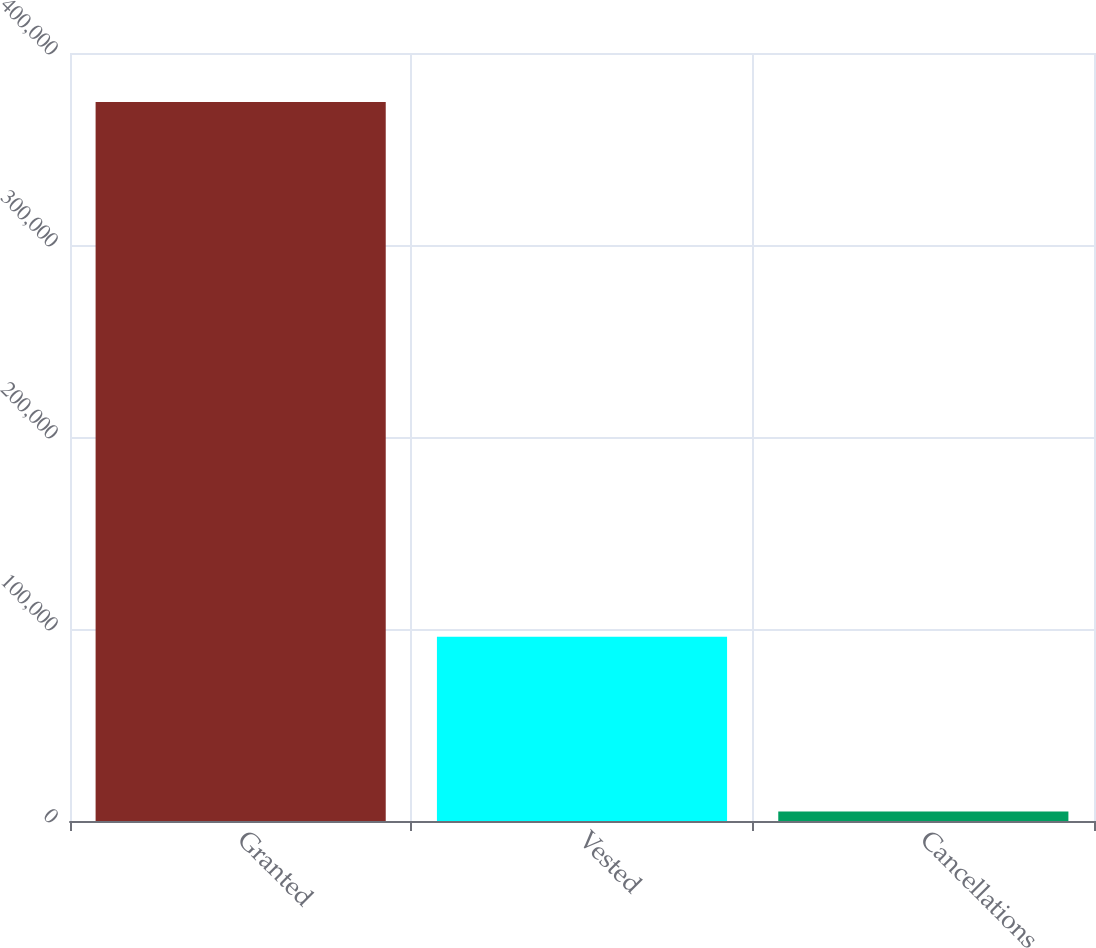<chart> <loc_0><loc_0><loc_500><loc_500><bar_chart><fcel>Granted<fcel>Vested<fcel>Cancellations<nl><fcel>374455<fcel>95995<fcel>4895<nl></chart> 